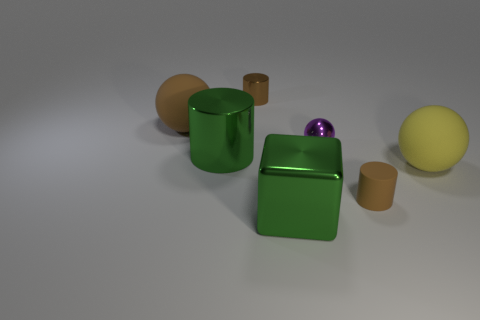Add 3 yellow objects. How many objects exist? 10 Subtract all blocks. How many objects are left? 6 Add 3 purple shiny objects. How many purple shiny objects exist? 4 Subtract 0 blue cubes. How many objects are left? 7 Subtract all yellow balls. Subtract all yellow matte things. How many objects are left? 5 Add 6 metal blocks. How many metal blocks are left? 7 